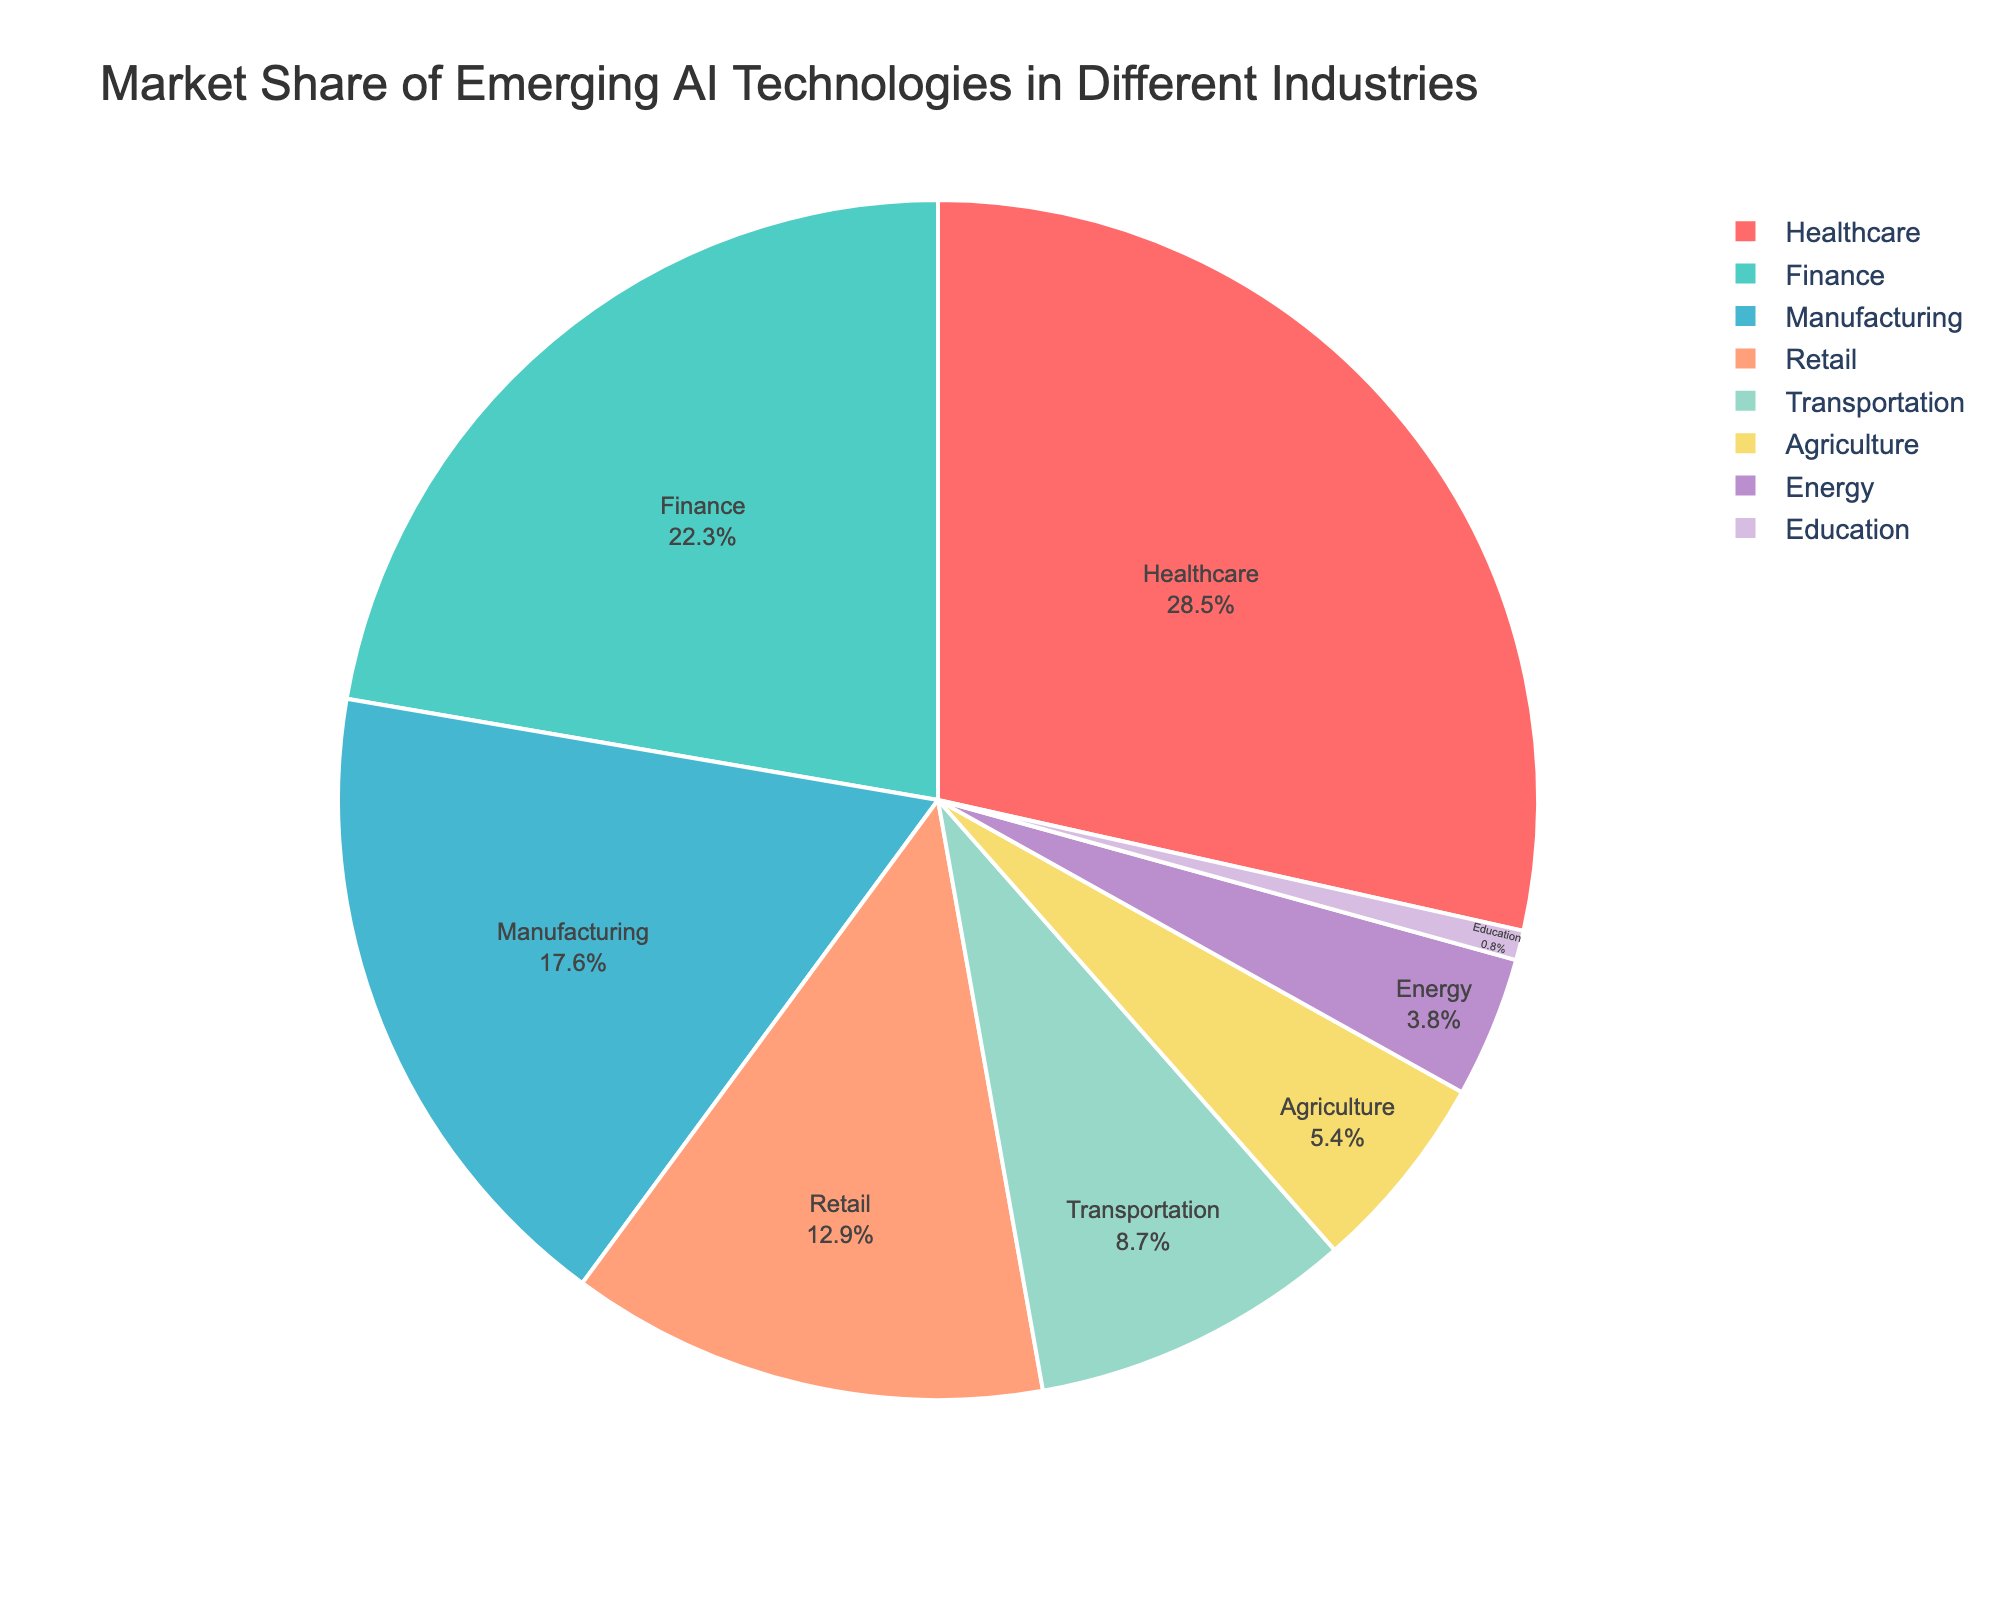Which industry has the largest market share of emerging AI technologies? Looking at the pie chart, the sector with the largest segment is identified. This segment represents the healthcare industry.
Answer: Healthcare How much higher is the market share of Healthcare compared to Education? Healthcare has a market share of 28.5%, while Education has a market share of 0.8%. Subtract the market share of Education from that of Healthcare: 28.5% - 0.8% = 27.7%.
Answer: 27.7% What is the combined market share of Finance and Manufacturing? Finance has a market share of 22.3% and Manufacturing has 17.6%. Adding these together yields 22.3% + 17.6% = 39.9%.
Answer: 39.9% Which industry has a greater market share, Agriculture or Energy? From the pie chart, Agriculture has a market share of 5.4% while Energy has 3.8%. Since 5.4% is greater than 3.8%, Agriculture has a greater market share.
Answer: Agriculture What percentage of the market is controlled by industries other than the top three? The top three industries are Healthcare (28.5%), Finance (22.3%), and Manufacturing (17.6%). Sum these to get the combined market share of the top three: 28.5% + 22.3% + 17.6% = 68.4%. The remaining market share is 100% - 68.4% = 31.6%.
Answer: 31.6% Compare the total market share of Healthcare and Transportation with that of Retail and Agriculture. Healthcare has 28.5% and Transportation has 8.7%, summing these gives 28.5% + 8.7% = 37.2%. Retail has 12.9% and Agriculture has 5.4%, summing these gives 12.9% + 5.4% = 18.3%. Thus, the combined market share of Healthcare and Transportation (37.2%) is greater than that of Retail and Agriculture (18.3%).
Answer: Healthcare and Transportation Which industry has the smallest market share, and what percentage is it? The smallest segment on the pie chart represents the Education industry. The market share of Education is 0.8%.
Answer: Education, 0.8% What is the average market share of the given industries? To find the average, add all the market shares together and then divide by the number of industries. The market shares sum to 28.5 + 22.3 + 17.6 + 12.9 + 8.7 + 5.4 + 3.8 + 0.8 = 100%. There are 8 industries. The average is 100% / 8 = 12.5%.
Answer: 12.5% How does the market share of Retail compare to that of Manufacturing? Retail has a market share of 12.9%, and Manufacturing has 17.6%. Since 17.6% is greater than 12.9%, Manufacturing has a larger market share than Retail.
Answer: Manufacturing What percentage of the market share do the top four industries control? The top four industries are Healthcare, Finance, Manufacturing, and Retail. Adding their market shares together: 28.5% + 22.3% + 17.6% + 12.9% = 81.3%.
Answer: 81.3% 